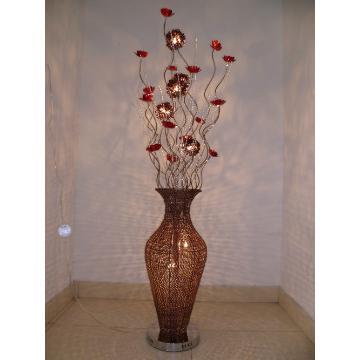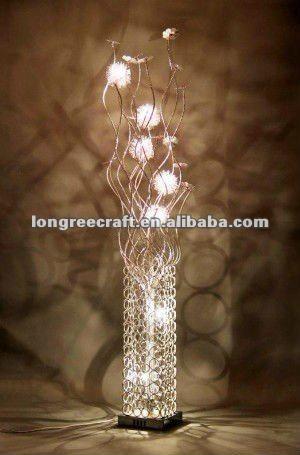The first image is the image on the left, the second image is the image on the right. For the images displayed, is the sentence "There is a silver lamp with white lights in the right image." factually correct? Answer yes or no. Yes. 